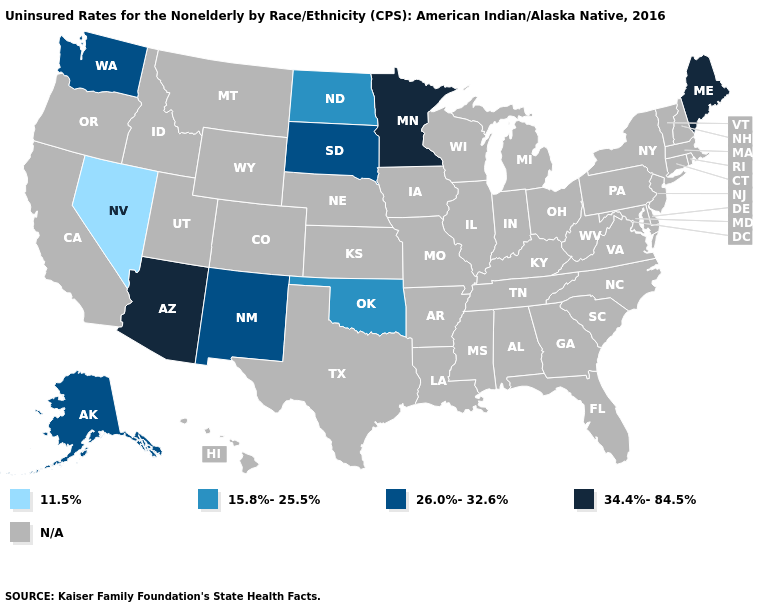Name the states that have a value in the range 26.0%-32.6%?
Be succinct. Alaska, New Mexico, South Dakota, Washington. Name the states that have a value in the range 11.5%?
Give a very brief answer. Nevada. Does the map have missing data?
Keep it brief. Yes. Name the states that have a value in the range 26.0%-32.6%?
Quick response, please. Alaska, New Mexico, South Dakota, Washington. What is the value of Vermont?
Give a very brief answer. N/A. Which states have the lowest value in the Northeast?
Keep it brief. Maine. Which states have the lowest value in the USA?
Short answer required. Nevada. What is the lowest value in the South?
Keep it brief. 15.8%-25.5%. What is the lowest value in the USA?
Answer briefly. 11.5%. What is the value of Washington?
Answer briefly. 26.0%-32.6%. Does Maine have the highest value in the USA?
Answer briefly. Yes. Does Minnesota have the highest value in the USA?
Be succinct. Yes. Which states have the lowest value in the MidWest?
Write a very short answer. North Dakota. 